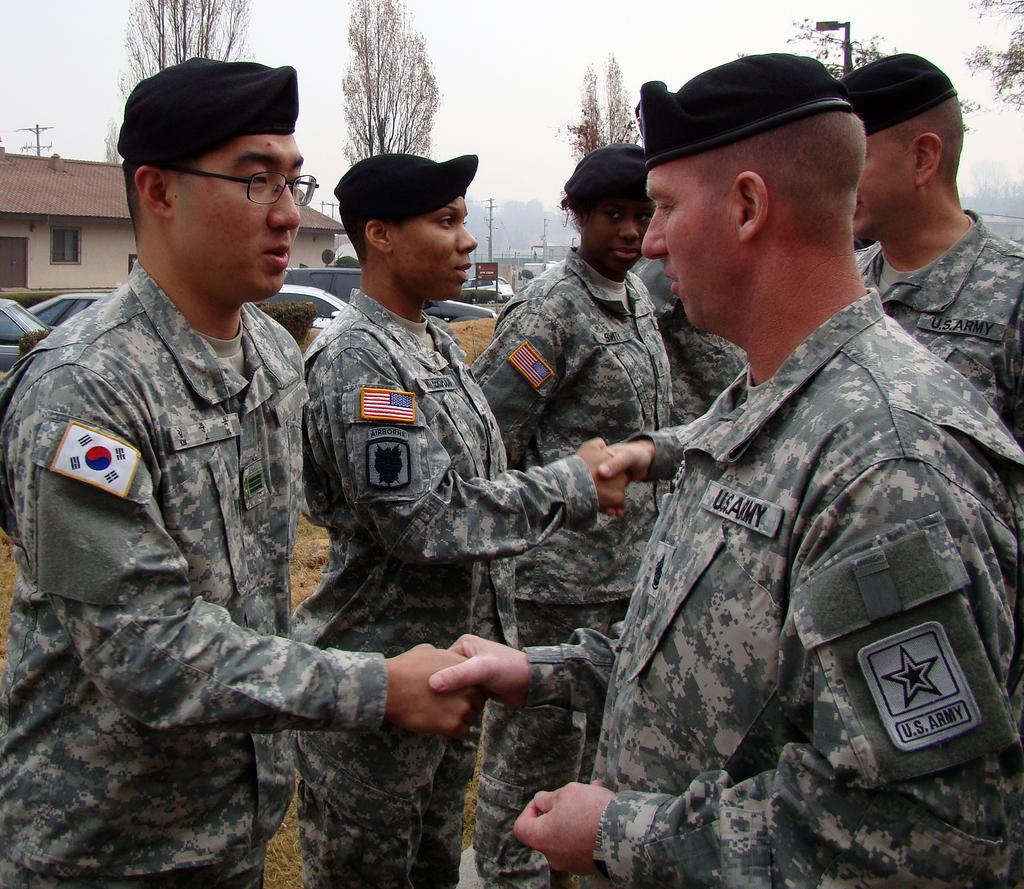How many people are in the image? There is a group of people in the image. What are the people wearing on their heads? The people are wearing caps. What can be seen in the background of the image? There are cars, trees, poles, and a house visible in the background. What type of glue is being used to attach the ornament to the story in the image? There is no glue, ornament, or story present in the image. 